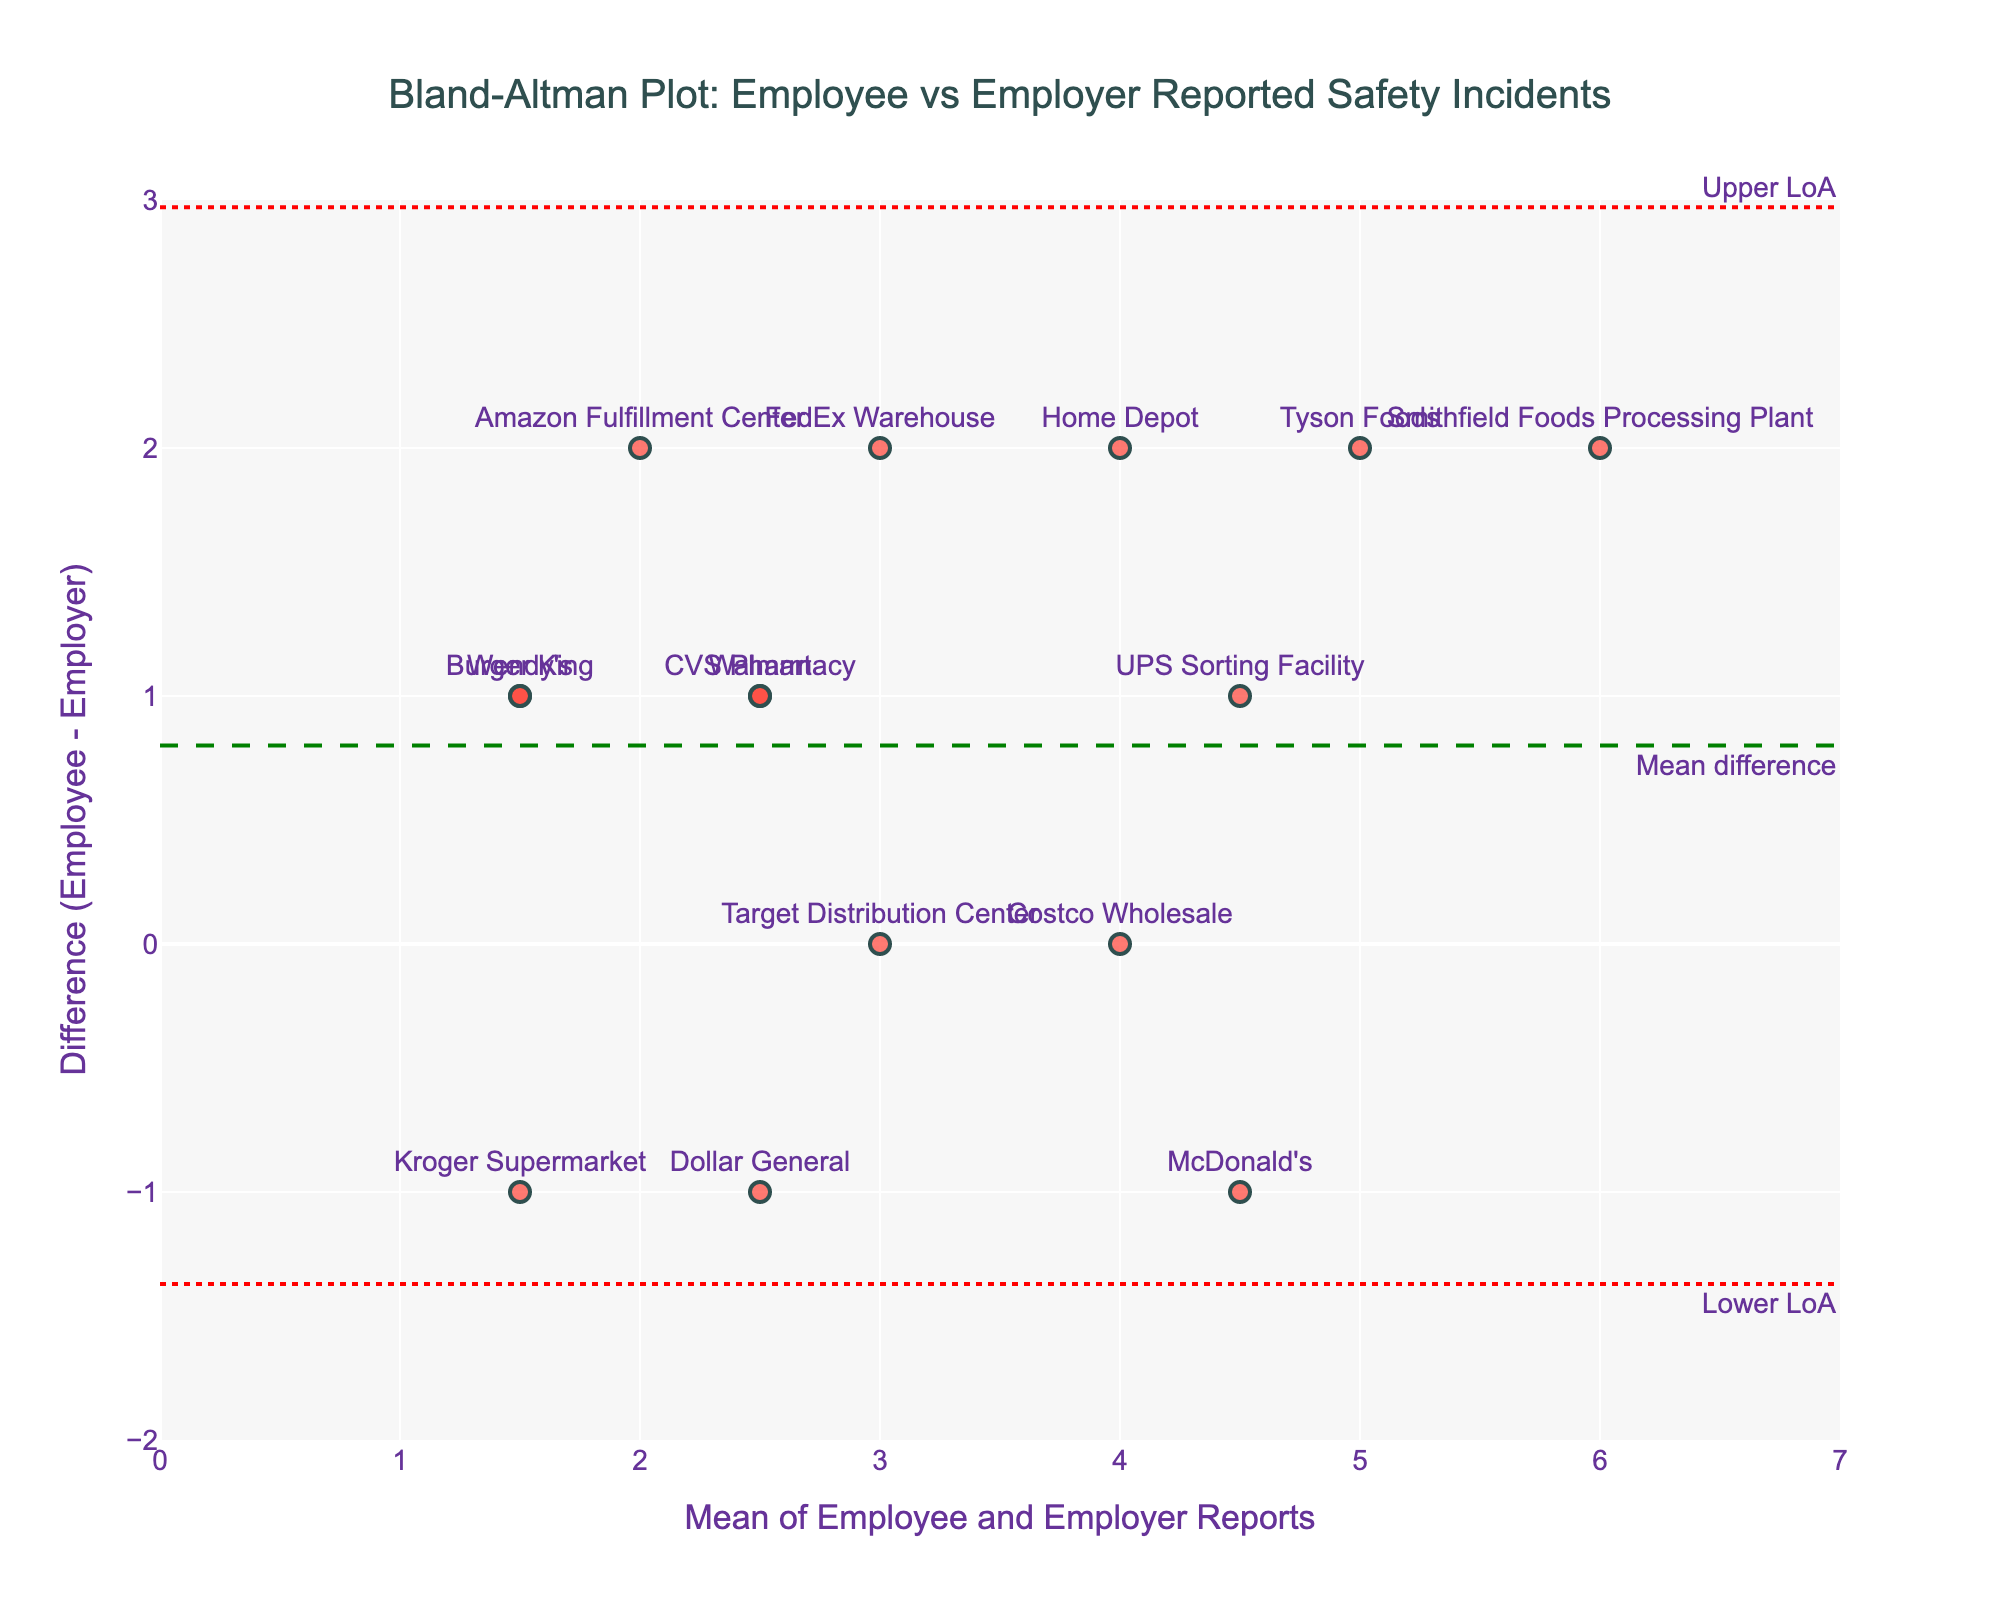What's the title of the plot? The title is usually displayed at the top of the figure. In this case, the given code specifies the title as "Bland-Altman Plot: Employee vs Employer Reported Safety Incidents."
Answer: Bland-Altman Plot: Employee vs Employer Reported Safety Incidents What do the x-axis and y-axis represent? The x-axis represents the mean of employee and employer reports, while the y-axis represents the difference between employee and employer reports. These definitions are given in the code setting the x-axis and y-axis titles.
Answer: Mean of Employee and Employer Reports; Difference (Employee - Employer) How many companies are represented in the plot? The number of companies corresponds to the number of data points on the plot. By quickly counting all unique markers and labels, you can determine this number.
Answer: 15 companies What's the difference between employee-reported and employer-reported incidents for McDonald's? To find this, locate the data point representing McDonald's, then read the value on the y-axis where its marker is positioned.
Answer: -1 Is there a trend in the differences between employee and employer reports as the mean value increases? By looking at the scatter of points and how they relate to the x-axis (mean), it does not show a clear upward or downward trend. The points are scattered without a visible pattern indicating a trend.
Answer: No clear trend What is the mean difference between employee-reported and employer-reported incidents? The mean difference is represented by the green dashed line on the y-axis. This line is explicitly labeled as "Mean difference."
Answer: 0.9333 What are the upper and lower limits of agreement (LoA)? The limits of agreement are shown as red dotted lines on the plot. They are labeled as "Upper LoA" and "Lower LoA" respectively. The exact values can be read from the plot.
Answer: Upper LoA: 4.27; Lower LoA: -2.40 Which company shows the largest positive difference between employee and employer reports? To determine this, look for the data point highest along the y-axis (difference) and note the associated company label.
Answer: Smithfield Foods Processing Plant How many companies have a negative difference between employee and employer reports? Count the number of data points that are below the zero line on the y-axis, representing a negative difference.
Answer: 5 companies What is the mean value of incidents reported by both employee and employer at Costco Wholesale? To find this, look for the data point corresponding to Costco Wholesale and read its x-axis value (mean).
Answer: 4 